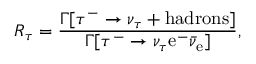Convert formula to latex. <formula><loc_0><loc_0><loc_500><loc_500>R _ { \tau } = \frac { \Gamma [ \tau ^ { - } \rightarrow \nu _ { \tau } + h a d r o n s ] } { \Gamma [ \tau ^ { - } \rightarrow \nu _ { \tau } e ^ { - } \bar { \nu } _ { e } ] } ,</formula> 